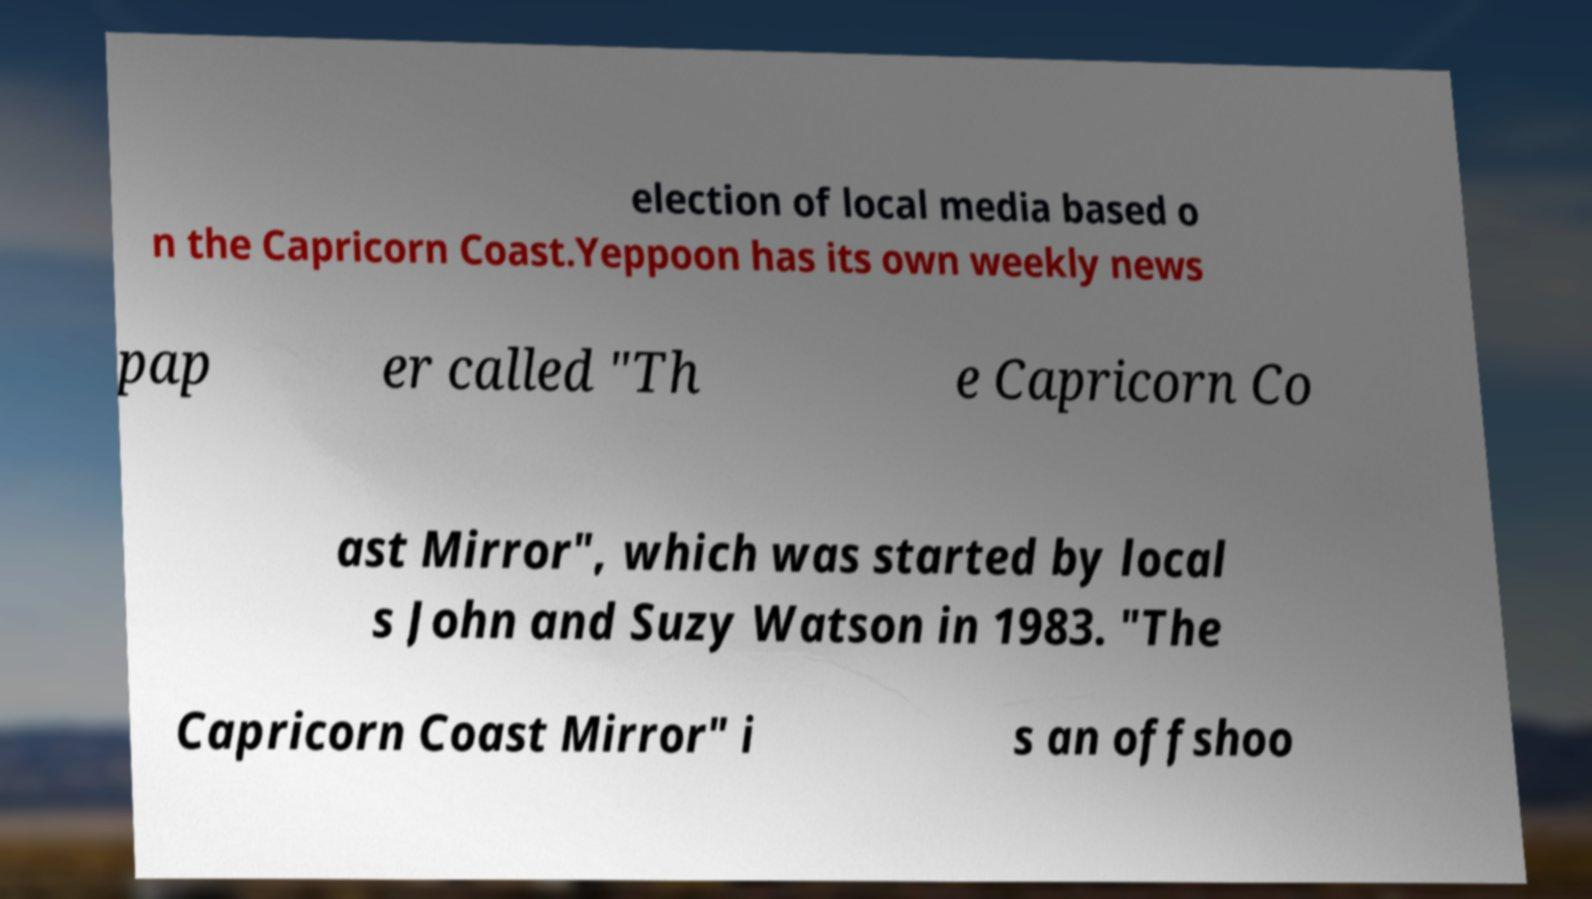There's text embedded in this image that I need extracted. Can you transcribe it verbatim? election of local media based o n the Capricorn Coast.Yeppoon has its own weekly news pap er called "Th e Capricorn Co ast Mirror", which was started by local s John and Suzy Watson in 1983. "The Capricorn Coast Mirror" i s an offshoo 